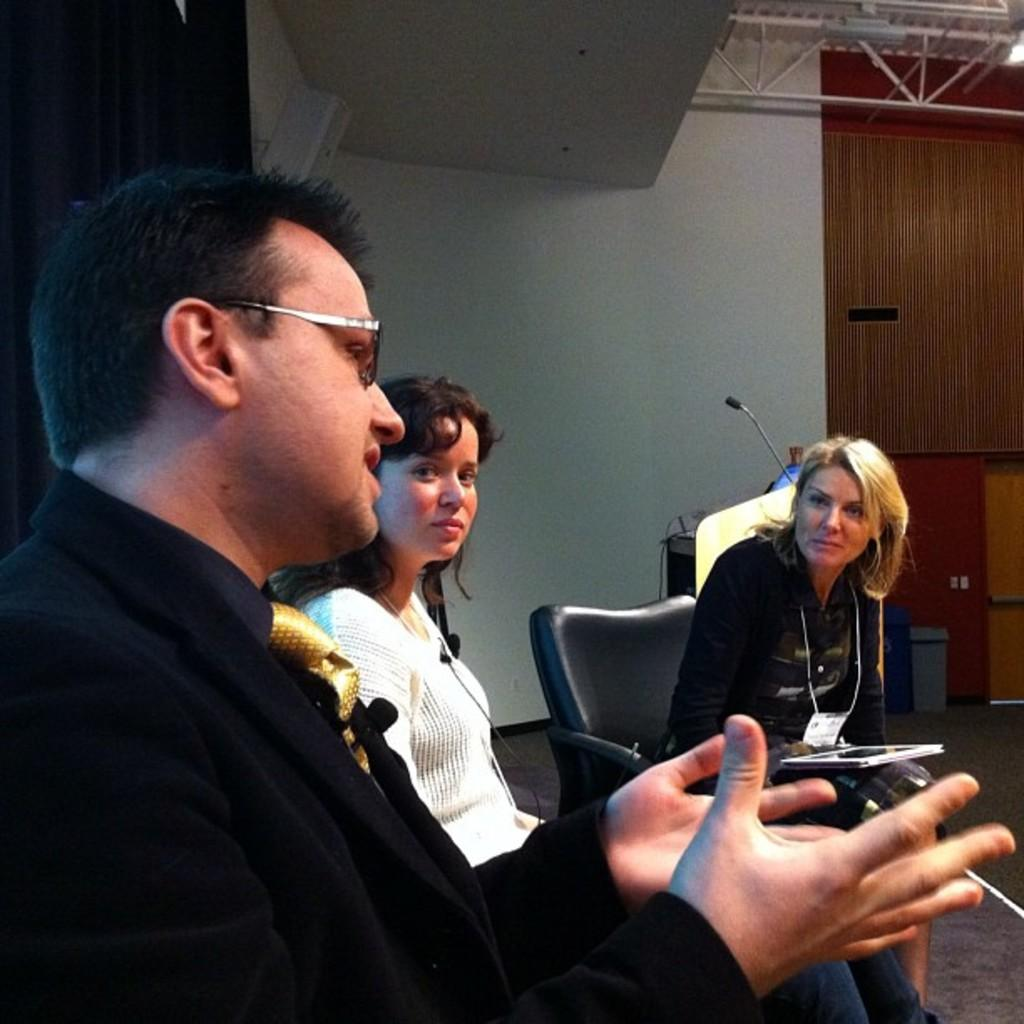How many people are in the image? There are three persons in the image. What are the persons doing in the image? The persons are discussing. Can you describe any architectural features in the image? Yes, there is a fencing attached to the roof in the image. What type of zipper can be seen on the boot in the image? There is no zipper or boot present in the image. How many buckets are visible in the image? There are no buckets visible in the image. 